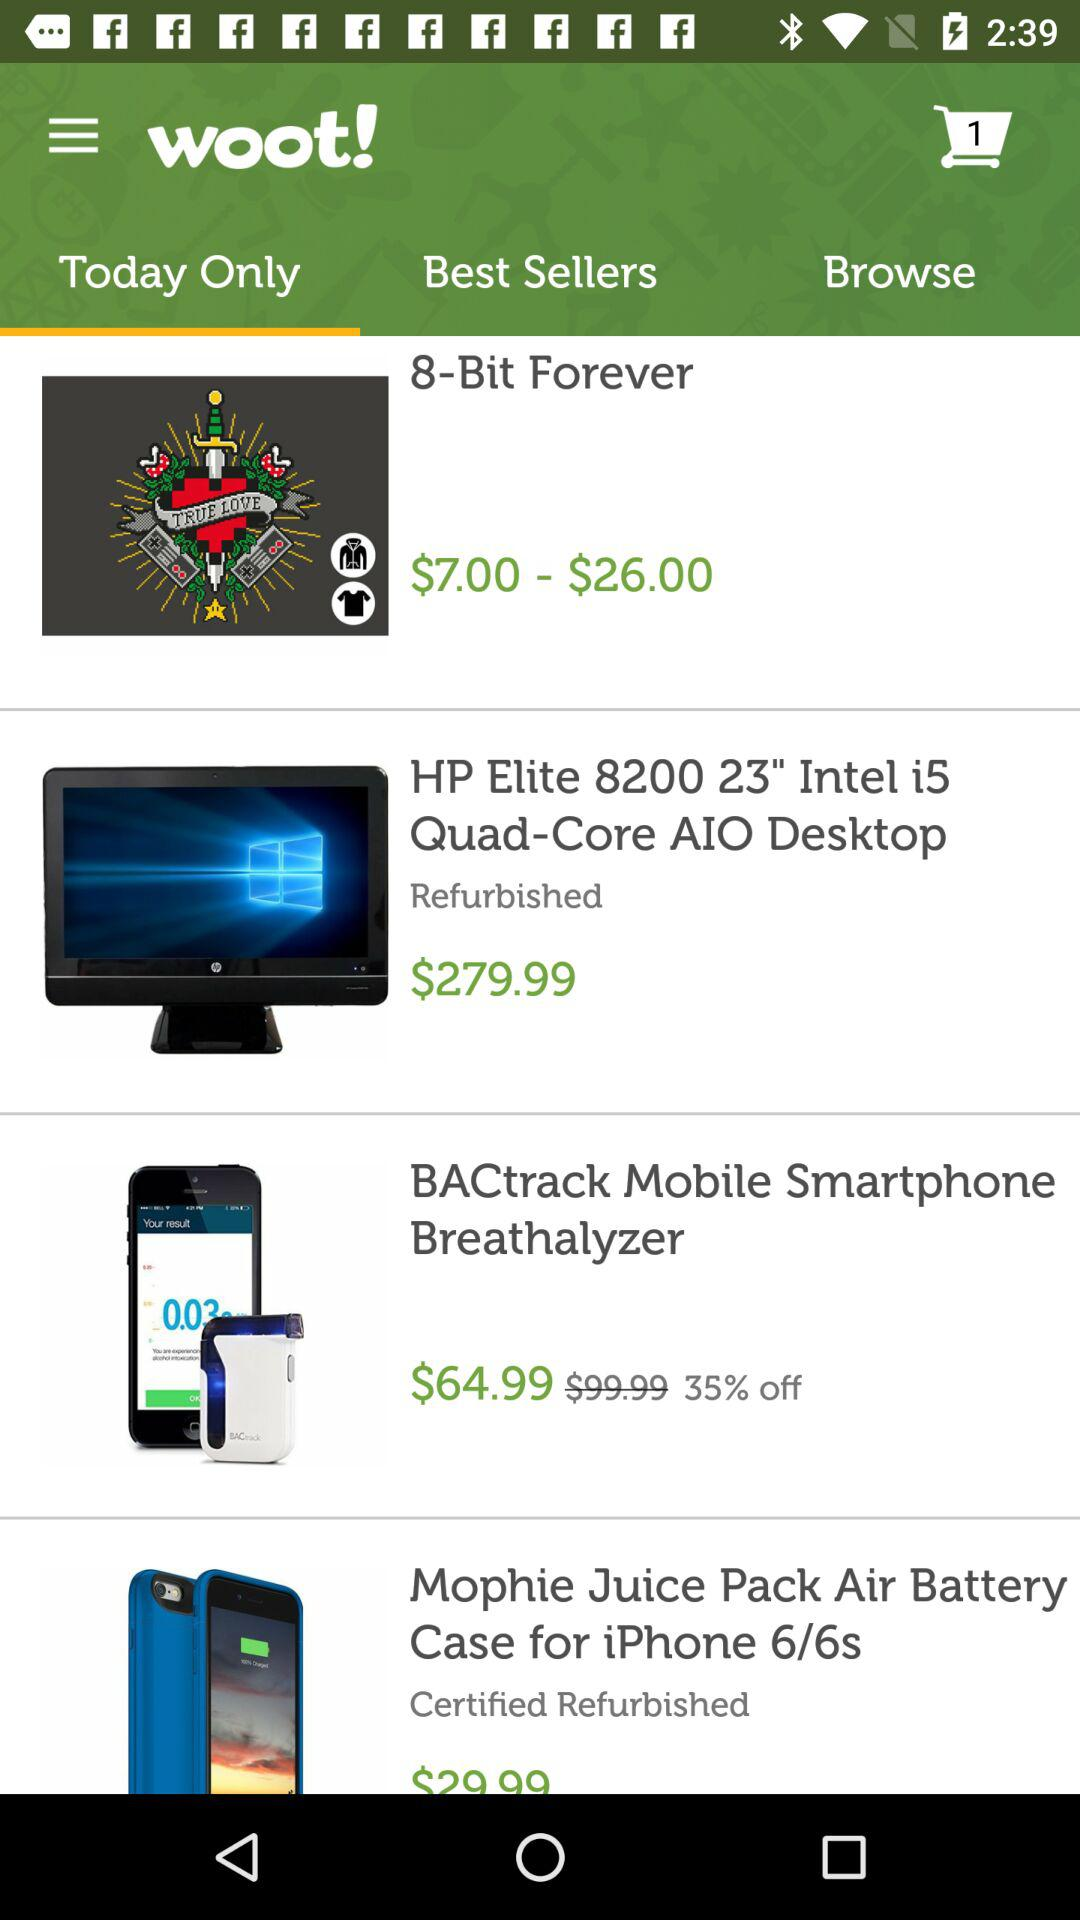What is the name of the application? The name of the application is "woot!". 